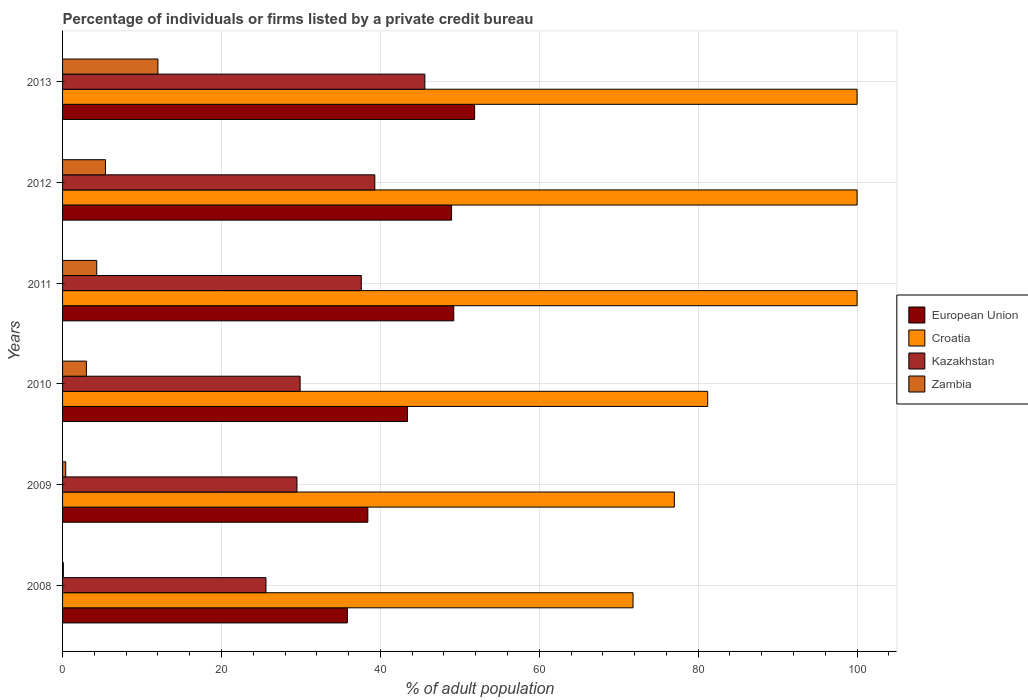How many different coloured bars are there?
Offer a very short reply. 4. How many groups of bars are there?
Offer a terse response. 6. Are the number of bars on each tick of the Y-axis equal?
Your answer should be very brief. Yes. How many bars are there on the 3rd tick from the top?
Provide a short and direct response. 4. How many bars are there on the 4th tick from the bottom?
Make the answer very short. 4. What is the label of the 1st group of bars from the top?
Your answer should be compact. 2013. What is the percentage of population listed by a private credit bureau in Zambia in 2011?
Give a very brief answer. 4.3. Across all years, what is the maximum percentage of population listed by a private credit bureau in Kazakhstan?
Your answer should be compact. 45.6. Across all years, what is the minimum percentage of population listed by a private credit bureau in Kazakhstan?
Ensure brevity in your answer.  25.6. In which year was the percentage of population listed by a private credit bureau in Kazakhstan maximum?
Offer a terse response. 2013. What is the total percentage of population listed by a private credit bureau in Zambia in the graph?
Provide a short and direct response. 25.2. What is the difference between the percentage of population listed by a private credit bureau in European Union in 2011 and the percentage of population listed by a private credit bureau in Croatia in 2008?
Provide a short and direct response. -22.56. In the year 2008, what is the difference between the percentage of population listed by a private credit bureau in Croatia and percentage of population listed by a private credit bureau in Zambia?
Keep it short and to the point. 71.7. In how many years, is the percentage of population listed by a private credit bureau in Kazakhstan greater than 56 %?
Provide a succinct answer. 0. What is the ratio of the percentage of population listed by a private credit bureau in European Union in 2009 to that in 2011?
Give a very brief answer. 0.78. Is the difference between the percentage of population listed by a private credit bureau in Croatia in 2011 and 2012 greater than the difference between the percentage of population listed by a private credit bureau in Zambia in 2011 and 2012?
Your answer should be compact. Yes. What is the difference between the highest and the lowest percentage of population listed by a private credit bureau in Kazakhstan?
Keep it short and to the point. 20. Is it the case that in every year, the sum of the percentage of population listed by a private credit bureau in Zambia and percentage of population listed by a private credit bureau in Croatia is greater than the sum of percentage of population listed by a private credit bureau in European Union and percentage of population listed by a private credit bureau in Kazakhstan?
Your answer should be compact. Yes. What does the 1st bar from the top in 2010 represents?
Your answer should be compact. Zambia. What does the 4th bar from the bottom in 2008 represents?
Give a very brief answer. Zambia. How many bars are there?
Your answer should be compact. 24. How many years are there in the graph?
Your answer should be very brief. 6. What is the difference between two consecutive major ticks on the X-axis?
Ensure brevity in your answer.  20. Are the values on the major ticks of X-axis written in scientific E-notation?
Ensure brevity in your answer.  No. Does the graph contain any zero values?
Your response must be concise. No. Does the graph contain grids?
Give a very brief answer. Yes. How many legend labels are there?
Keep it short and to the point. 4. What is the title of the graph?
Offer a terse response. Percentage of individuals or firms listed by a private credit bureau. What is the label or title of the X-axis?
Offer a very short reply. % of adult population. What is the label or title of the Y-axis?
Give a very brief answer. Years. What is the % of adult population of European Union in 2008?
Your answer should be compact. 35.84. What is the % of adult population of Croatia in 2008?
Your answer should be very brief. 71.8. What is the % of adult population of Kazakhstan in 2008?
Provide a short and direct response. 25.6. What is the % of adult population of European Union in 2009?
Give a very brief answer. 38.42. What is the % of adult population of Kazakhstan in 2009?
Your response must be concise. 29.5. What is the % of adult population of European Union in 2010?
Offer a terse response. 43.41. What is the % of adult population in Croatia in 2010?
Keep it short and to the point. 81.2. What is the % of adult population of Kazakhstan in 2010?
Your response must be concise. 29.9. What is the % of adult population of European Union in 2011?
Your answer should be compact. 49.24. What is the % of adult population of Croatia in 2011?
Offer a very short reply. 100. What is the % of adult population in Kazakhstan in 2011?
Keep it short and to the point. 37.6. What is the % of adult population of European Union in 2012?
Ensure brevity in your answer.  48.96. What is the % of adult population of Croatia in 2012?
Your answer should be compact. 100. What is the % of adult population of Kazakhstan in 2012?
Your answer should be very brief. 39.3. What is the % of adult population in European Union in 2013?
Give a very brief answer. 51.86. What is the % of adult population of Kazakhstan in 2013?
Make the answer very short. 45.6. Across all years, what is the maximum % of adult population of European Union?
Provide a short and direct response. 51.86. Across all years, what is the maximum % of adult population of Kazakhstan?
Make the answer very short. 45.6. Across all years, what is the minimum % of adult population of European Union?
Ensure brevity in your answer.  35.84. Across all years, what is the minimum % of adult population in Croatia?
Your response must be concise. 71.8. Across all years, what is the minimum % of adult population of Kazakhstan?
Make the answer very short. 25.6. Across all years, what is the minimum % of adult population of Zambia?
Offer a terse response. 0.1. What is the total % of adult population in European Union in the graph?
Ensure brevity in your answer.  267.75. What is the total % of adult population in Croatia in the graph?
Provide a succinct answer. 530. What is the total % of adult population in Kazakhstan in the graph?
Your answer should be compact. 207.5. What is the total % of adult population of Zambia in the graph?
Keep it short and to the point. 25.2. What is the difference between the % of adult population of European Union in 2008 and that in 2009?
Make the answer very short. -2.58. What is the difference between the % of adult population in European Union in 2008 and that in 2010?
Provide a succinct answer. -7.57. What is the difference between the % of adult population of Croatia in 2008 and that in 2010?
Provide a short and direct response. -9.4. What is the difference between the % of adult population in European Union in 2008 and that in 2011?
Your response must be concise. -13.39. What is the difference between the % of adult population in Croatia in 2008 and that in 2011?
Give a very brief answer. -28.2. What is the difference between the % of adult population in Kazakhstan in 2008 and that in 2011?
Offer a terse response. -12. What is the difference between the % of adult population in Zambia in 2008 and that in 2011?
Provide a succinct answer. -4.2. What is the difference between the % of adult population of European Union in 2008 and that in 2012?
Offer a terse response. -13.12. What is the difference between the % of adult population in Croatia in 2008 and that in 2012?
Provide a short and direct response. -28.2. What is the difference between the % of adult population in Kazakhstan in 2008 and that in 2012?
Offer a terse response. -13.7. What is the difference between the % of adult population of European Union in 2008 and that in 2013?
Give a very brief answer. -16.02. What is the difference between the % of adult population of Croatia in 2008 and that in 2013?
Provide a succinct answer. -28.2. What is the difference between the % of adult population in Zambia in 2008 and that in 2013?
Give a very brief answer. -11.9. What is the difference between the % of adult population of European Union in 2009 and that in 2010?
Offer a terse response. -4.99. What is the difference between the % of adult population of Kazakhstan in 2009 and that in 2010?
Offer a terse response. -0.4. What is the difference between the % of adult population in European Union in 2009 and that in 2011?
Your answer should be very brief. -10.82. What is the difference between the % of adult population of European Union in 2009 and that in 2012?
Your answer should be very brief. -10.54. What is the difference between the % of adult population of Croatia in 2009 and that in 2012?
Ensure brevity in your answer.  -23. What is the difference between the % of adult population in European Union in 2009 and that in 2013?
Offer a terse response. -13.44. What is the difference between the % of adult population in Kazakhstan in 2009 and that in 2013?
Give a very brief answer. -16.1. What is the difference between the % of adult population in Zambia in 2009 and that in 2013?
Offer a terse response. -11.6. What is the difference between the % of adult population of European Union in 2010 and that in 2011?
Offer a very short reply. -5.82. What is the difference between the % of adult population of Croatia in 2010 and that in 2011?
Make the answer very short. -18.8. What is the difference between the % of adult population of European Union in 2010 and that in 2012?
Provide a short and direct response. -5.55. What is the difference between the % of adult population of Croatia in 2010 and that in 2012?
Provide a succinct answer. -18.8. What is the difference between the % of adult population of Kazakhstan in 2010 and that in 2012?
Your answer should be very brief. -9.4. What is the difference between the % of adult population in Zambia in 2010 and that in 2012?
Offer a very short reply. -2.4. What is the difference between the % of adult population of European Union in 2010 and that in 2013?
Provide a succinct answer. -8.45. What is the difference between the % of adult population of Croatia in 2010 and that in 2013?
Provide a succinct answer. -18.8. What is the difference between the % of adult population of Kazakhstan in 2010 and that in 2013?
Ensure brevity in your answer.  -15.7. What is the difference between the % of adult population of Zambia in 2010 and that in 2013?
Keep it short and to the point. -9. What is the difference between the % of adult population of European Union in 2011 and that in 2012?
Make the answer very short. 0.28. What is the difference between the % of adult population of European Union in 2011 and that in 2013?
Ensure brevity in your answer.  -2.62. What is the difference between the % of adult population of Kazakhstan in 2011 and that in 2013?
Your response must be concise. -8. What is the difference between the % of adult population of European Union in 2012 and that in 2013?
Provide a succinct answer. -2.9. What is the difference between the % of adult population of Croatia in 2012 and that in 2013?
Ensure brevity in your answer.  0. What is the difference between the % of adult population in European Union in 2008 and the % of adult population in Croatia in 2009?
Your answer should be very brief. -41.16. What is the difference between the % of adult population of European Union in 2008 and the % of adult population of Kazakhstan in 2009?
Provide a short and direct response. 6.34. What is the difference between the % of adult population of European Union in 2008 and the % of adult population of Zambia in 2009?
Ensure brevity in your answer.  35.44. What is the difference between the % of adult population of Croatia in 2008 and the % of adult population of Kazakhstan in 2009?
Your response must be concise. 42.3. What is the difference between the % of adult population in Croatia in 2008 and the % of adult population in Zambia in 2009?
Give a very brief answer. 71.4. What is the difference between the % of adult population of Kazakhstan in 2008 and the % of adult population of Zambia in 2009?
Keep it short and to the point. 25.2. What is the difference between the % of adult population in European Union in 2008 and the % of adult population in Croatia in 2010?
Your answer should be very brief. -45.36. What is the difference between the % of adult population in European Union in 2008 and the % of adult population in Kazakhstan in 2010?
Your answer should be very brief. 5.94. What is the difference between the % of adult population of European Union in 2008 and the % of adult population of Zambia in 2010?
Your response must be concise. 32.84. What is the difference between the % of adult population in Croatia in 2008 and the % of adult population in Kazakhstan in 2010?
Your response must be concise. 41.9. What is the difference between the % of adult population of Croatia in 2008 and the % of adult population of Zambia in 2010?
Offer a terse response. 68.8. What is the difference between the % of adult population in Kazakhstan in 2008 and the % of adult population in Zambia in 2010?
Offer a very short reply. 22.6. What is the difference between the % of adult population in European Union in 2008 and the % of adult population in Croatia in 2011?
Your answer should be very brief. -64.16. What is the difference between the % of adult population in European Union in 2008 and the % of adult population in Kazakhstan in 2011?
Provide a succinct answer. -1.76. What is the difference between the % of adult population of European Union in 2008 and the % of adult population of Zambia in 2011?
Your answer should be compact. 31.54. What is the difference between the % of adult population in Croatia in 2008 and the % of adult population in Kazakhstan in 2011?
Offer a terse response. 34.2. What is the difference between the % of adult population of Croatia in 2008 and the % of adult population of Zambia in 2011?
Your answer should be very brief. 67.5. What is the difference between the % of adult population of Kazakhstan in 2008 and the % of adult population of Zambia in 2011?
Offer a terse response. 21.3. What is the difference between the % of adult population in European Union in 2008 and the % of adult population in Croatia in 2012?
Provide a succinct answer. -64.16. What is the difference between the % of adult population of European Union in 2008 and the % of adult population of Kazakhstan in 2012?
Give a very brief answer. -3.46. What is the difference between the % of adult population of European Union in 2008 and the % of adult population of Zambia in 2012?
Provide a short and direct response. 30.44. What is the difference between the % of adult population of Croatia in 2008 and the % of adult population of Kazakhstan in 2012?
Keep it short and to the point. 32.5. What is the difference between the % of adult population of Croatia in 2008 and the % of adult population of Zambia in 2012?
Provide a succinct answer. 66.4. What is the difference between the % of adult population in Kazakhstan in 2008 and the % of adult population in Zambia in 2012?
Provide a short and direct response. 20.2. What is the difference between the % of adult population in European Union in 2008 and the % of adult population in Croatia in 2013?
Provide a short and direct response. -64.16. What is the difference between the % of adult population in European Union in 2008 and the % of adult population in Kazakhstan in 2013?
Provide a short and direct response. -9.76. What is the difference between the % of adult population of European Union in 2008 and the % of adult population of Zambia in 2013?
Keep it short and to the point. 23.84. What is the difference between the % of adult population in Croatia in 2008 and the % of adult population in Kazakhstan in 2013?
Offer a very short reply. 26.2. What is the difference between the % of adult population in Croatia in 2008 and the % of adult population in Zambia in 2013?
Give a very brief answer. 59.8. What is the difference between the % of adult population in European Union in 2009 and the % of adult population in Croatia in 2010?
Provide a succinct answer. -42.78. What is the difference between the % of adult population in European Union in 2009 and the % of adult population in Kazakhstan in 2010?
Provide a short and direct response. 8.52. What is the difference between the % of adult population in European Union in 2009 and the % of adult population in Zambia in 2010?
Your answer should be compact. 35.42. What is the difference between the % of adult population in Croatia in 2009 and the % of adult population in Kazakhstan in 2010?
Provide a succinct answer. 47.1. What is the difference between the % of adult population of Croatia in 2009 and the % of adult population of Zambia in 2010?
Provide a succinct answer. 74. What is the difference between the % of adult population in Kazakhstan in 2009 and the % of adult population in Zambia in 2010?
Give a very brief answer. 26.5. What is the difference between the % of adult population in European Union in 2009 and the % of adult population in Croatia in 2011?
Provide a succinct answer. -61.58. What is the difference between the % of adult population of European Union in 2009 and the % of adult population of Kazakhstan in 2011?
Your response must be concise. 0.82. What is the difference between the % of adult population of European Union in 2009 and the % of adult population of Zambia in 2011?
Provide a succinct answer. 34.12. What is the difference between the % of adult population in Croatia in 2009 and the % of adult population in Kazakhstan in 2011?
Ensure brevity in your answer.  39.4. What is the difference between the % of adult population of Croatia in 2009 and the % of adult population of Zambia in 2011?
Keep it short and to the point. 72.7. What is the difference between the % of adult population of Kazakhstan in 2009 and the % of adult population of Zambia in 2011?
Make the answer very short. 25.2. What is the difference between the % of adult population in European Union in 2009 and the % of adult population in Croatia in 2012?
Your response must be concise. -61.58. What is the difference between the % of adult population in European Union in 2009 and the % of adult population in Kazakhstan in 2012?
Offer a terse response. -0.88. What is the difference between the % of adult population in European Union in 2009 and the % of adult population in Zambia in 2012?
Make the answer very short. 33.02. What is the difference between the % of adult population in Croatia in 2009 and the % of adult population in Kazakhstan in 2012?
Offer a terse response. 37.7. What is the difference between the % of adult population of Croatia in 2009 and the % of adult population of Zambia in 2012?
Give a very brief answer. 71.6. What is the difference between the % of adult population of Kazakhstan in 2009 and the % of adult population of Zambia in 2012?
Ensure brevity in your answer.  24.1. What is the difference between the % of adult population of European Union in 2009 and the % of adult population of Croatia in 2013?
Your answer should be very brief. -61.58. What is the difference between the % of adult population in European Union in 2009 and the % of adult population in Kazakhstan in 2013?
Give a very brief answer. -7.18. What is the difference between the % of adult population of European Union in 2009 and the % of adult population of Zambia in 2013?
Provide a short and direct response. 26.42. What is the difference between the % of adult population in Croatia in 2009 and the % of adult population in Kazakhstan in 2013?
Provide a succinct answer. 31.4. What is the difference between the % of adult population of Kazakhstan in 2009 and the % of adult population of Zambia in 2013?
Give a very brief answer. 17.5. What is the difference between the % of adult population in European Union in 2010 and the % of adult population in Croatia in 2011?
Your response must be concise. -56.59. What is the difference between the % of adult population in European Union in 2010 and the % of adult population in Kazakhstan in 2011?
Offer a very short reply. 5.81. What is the difference between the % of adult population in European Union in 2010 and the % of adult population in Zambia in 2011?
Your answer should be very brief. 39.11. What is the difference between the % of adult population of Croatia in 2010 and the % of adult population of Kazakhstan in 2011?
Ensure brevity in your answer.  43.6. What is the difference between the % of adult population of Croatia in 2010 and the % of adult population of Zambia in 2011?
Keep it short and to the point. 76.9. What is the difference between the % of adult population in Kazakhstan in 2010 and the % of adult population in Zambia in 2011?
Provide a succinct answer. 25.6. What is the difference between the % of adult population in European Union in 2010 and the % of adult population in Croatia in 2012?
Keep it short and to the point. -56.59. What is the difference between the % of adult population of European Union in 2010 and the % of adult population of Kazakhstan in 2012?
Your answer should be very brief. 4.11. What is the difference between the % of adult population in European Union in 2010 and the % of adult population in Zambia in 2012?
Provide a succinct answer. 38.01. What is the difference between the % of adult population of Croatia in 2010 and the % of adult population of Kazakhstan in 2012?
Your answer should be very brief. 41.9. What is the difference between the % of adult population in Croatia in 2010 and the % of adult population in Zambia in 2012?
Your answer should be compact. 75.8. What is the difference between the % of adult population in Kazakhstan in 2010 and the % of adult population in Zambia in 2012?
Your answer should be very brief. 24.5. What is the difference between the % of adult population of European Union in 2010 and the % of adult population of Croatia in 2013?
Provide a short and direct response. -56.59. What is the difference between the % of adult population in European Union in 2010 and the % of adult population in Kazakhstan in 2013?
Keep it short and to the point. -2.19. What is the difference between the % of adult population of European Union in 2010 and the % of adult population of Zambia in 2013?
Ensure brevity in your answer.  31.41. What is the difference between the % of adult population of Croatia in 2010 and the % of adult population of Kazakhstan in 2013?
Your answer should be very brief. 35.6. What is the difference between the % of adult population in Croatia in 2010 and the % of adult population in Zambia in 2013?
Ensure brevity in your answer.  69.2. What is the difference between the % of adult population of European Union in 2011 and the % of adult population of Croatia in 2012?
Provide a short and direct response. -50.76. What is the difference between the % of adult population in European Union in 2011 and the % of adult population in Kazakhstan in 2012?
Your response must be concise. 9.94. What is the difference between the % of adult population of European Union in 2011 and the % of adult population of Zambia in 2012?
Your answer should be compact. 43.84. What is the difference between the % of adult population in Croatia in 2011 and the % of adult population in Kazakhstan in 2012?
Your answer should be compact. 60.7. What is the difference between the % of adult population of Croatia in 2011 and the % of adult population of Zambia in 2012?
Your answer should be compact. 94.6. What is the difference between the % of adult population in Kazakhstan in 2011 and the % of adult population in Zambia in 2012?
Give a very brief answer. 32.2. What is the difference between the % of adult population in European Union in 2011 and the % of adult population in Croatia in 2013?
Offer a terse response. -50.76. What is the difference between the % of adult population of European Union in 2011 and the % of adult population of Kazakhstan in 2013?
Make the answer very short. 3.64. What is the difference between the % of adult population of European Union in 2011 and the % of adult population of Zambia in 2013?
Your answer should be compact. 37.24. What is the difference between the % of adult population in Croatia in 2011 and the % of adult population in Kazakhstan in 2013?
Provide a succinct answer. 54.4. What is the difference between the % of adult population of Croatia in 2011 and the % of adult population of Zambia in 2013?
Offer a very short reply. 88. What is the difference between the % of adult population in Kazakhstan in 2011 and the % of adult population in Zambia in 2013?
Give a very brief answer. 25.6. What is the difference between the % of adult population in European Union in 2012 and the % of adult population in Croatia in 2013?
Provide a short and direct response. -51.04. What is the difference between the % of adult population of European Union in 2012 and the % of adult population of Kazakhstan in 2013?
Make the answer very short. 3.36. What is the difference between the % of adult population of European Union in 2012 and the % of adult population of Zambia in 2013?
Your answer should be compact. 36.96. What is the difference between the % of adult population in Croatia in 2012 and the % of adult population in Kazakhstan in 2013?
Make the answer very short. 54.4. What is the difference between the % of adult population of Croatia in 2012 and the % of adult population of Zambia in 2013?
Give a very brief answer. 88. What is the difference between the % of adult population of Kazakhstan in 2012 and the % of adult population of Zambia in 2013?
Your response must be concise. 27.3. What is the average % of adult population in European Union per year?
Offer a terse response. 44.62. What is the average % of adult population in Croatia per year?
Your answer should be compact. 88.33. What is the average % of adult population in Kazakhstan per year?
Ensure brevity in your answer.  34.58. What is the average % of adult population in Zambia per year?
Ensure brevity in your answer.  4.2. In the year 2008, what is the difference between the % of adult population in European Union and % of adult population in Croatia?
Offer a terse response. -35.96. In the year 2008, what is the difference between the % of adult population in European Union and % of adult population in Kazakhstan?
Give a very brief answer. 10.24. In the year 2008, what is the difference between the % of adult population in European Union and % of adult population in Zambia?
Your answer should be very brief. 35.74. In the year 2008, what is the difference between the % of adult population in Croatia and % of adult population in Kazakhstan?
Make the answer very short. 46.2. In the year 2008, what is the difference between the % of adult population of Croatia and % of adult population of Zambia?
Your answer should be very brief. 71.7. In the year 2008, what is the difference between the % of adult population in Kazakhstan and % of adult population in Zambia?
Keep it short and to the point. 25.5. In the year 2009, what is the difference between the % of adult population of European Union and % of adult population of Croatia?
Your answer should be very brief. -38.58. In the year 2009, what is the difference between the % of adult population of European Union and % of adult population of Kazakhstan?
Your response must be concise. 8.92. In the year 2009, what is the difference between the % of adult population of European Union and % of adult population of Zambia?
Your response must be concise. 38.02. In the year 2009, what is the difference between the % of adult population in Croatia and % of adult population in Kazakhstan?
Keep it short and to the point. 47.5. In the year 2009, what is the difference between the % of adult population in Croatia and % of adult population in Zambia?
Provide a short and direct response. 76.6. In the year 2009, what is the difference between the % of adult population of Kazakhstan and % of adult population of Zambia?
Make the answer very short. 29.1. In the year 2010, what is the difference between the % of adult population of European Union and % of adult population of Croatia?
Keep it short and to the point. -37.79. In the year 2010, what is the difference between the % of adult population of European Union and % of adult population of Kazakhstan?
Provide a short and direct response. 13.51. In the year 2010, what is the difference between the % of adult population in European Union and % of adult population in Zambia?
Your answer should be compact. 40.41. In the year 2010, what is the difference between the % of adult population in Croatia and % of adult population in Kazakhstan?
Make the answer very short. 51.3. In the year 2010, what is the difference between the % of adult population in Croatia and % of adult population in Zambia?
Your response must be concise. 78.2. In the year 2010, what is the difference between the % of adult population in Kazakhstan and % of adult population in Zambia?
Ensure brevity in your answer.  26.9. In the year 2011, what is the difference between the % of adult population in European Union and % of adult population in Croatia?
Provide a succinct answer. -50.76. In the year 2011, what is the difference between the % of adult population of European Union and % of adult population of Kazakhstan?
Your answer should be compact. 11.64. In the year 2011, what is the difference between the % of adult population of European Union and % of adult population of Zambia?
Keep it short and to the point. 44.94. In the year 2011, what is the difference between the % of adult population in Croatia and % of adult population in Kazakhstan?
Make the answer very short. 62.4. In the year 2011, what is the difference between the % of adult population in Croatia and % of adult population in Zambia?
Your answer should be compact. 95.7. In the year 2011, what is the difference between the % of adult population in Kazakhstan and % of adult population in Zambia?
Offer a very short reply. 33.3. In the year 2012, what is the difference between the % of adult population in European Union and % of adult population in Croatia?
Give a very brief answer. -51.04. In the year 2012, what is the difference between the % of adult population in European Union and % of adult population in Kazakhstan?
Ensure brevity in your answer.  9.66. In the year 2012, what is the difference between the % of adult population of European Union and % of adult population of Zambia?
Your answer should be compact. 43.56. In the year 2012, what is the difference between the % of adult population of Croatia and % of adult population of Kazakhstan?
Provide a short and direct response. 60.7. In the year 2012, what is the difference between the % of adult population in Croatia and % of adult population in Zambia?
Make the answer very short. 94.6. In the year 2012, what is the difference between the % of adult population in Kazakhstan and % of adult population in Zambia?
Give a very brief answer. 33.9. In the year 2013, what is the difference between the % of adult population in European Union and % of adult population in Croatia?
Give a very brief answer. -48.14. In the year 2013, what is the difference between the % of adult population in European Union and % of adult population in Kazakhstan?
Provide a short and direct response. 6.26. In the year 2013, what is the difference between the % of adult population of European Union and % of adult population of Zambia?
Offer a terse response. 39.86. In the year 2013, what is the difference between the % of adult population of Croatia and % of adult population of Kazakhstan?
Make the answer very short. 54.4. In the year 2013, what is the difference between the % of adult population of Croatia and % of adult population of Zambia?
Ensure brevity in your answer.  88. In the year 2013, what is the difference between the % of adult population in Kazakhstan and % of adult population in Zambia?
Give a very brief answer. 33.6. What is the ratio of the % of adult population in European Union in 2008 to that in 2009?
Your answer should be compact. 0.93. What is the ratio of the % of adult population in Croatia in 2008 to that in 2009?
Provide a succinct answer. 0.93. What is the ratio of the % of adult population in Kazakhstan in 2008 to that in 2009?
Provide a short and direct response. 0.87. What is the ratio of the % of adult population of Zambia in 2008 to that in 2009?
Offer a very short reply. 0.25. What is the ratio of the % of adult population in European Union in 2008 to that in 2010?
Offer a very short reply. 0.83. What is the ratio of the % of adult population in Croatia in 2008 to that in 2010?
Ensure brevity in your answer.  0.88. What is the ratio of the % of adult population of Kazakhstan in 2008 to that in 2010?
Your response must be concise. 0.86. What is the ratio of the % of adult population in Zambia in 2008 to that in 2010?
Keep it short and to the point. 0.03. What is the ratio of the % of adult population in European Union in 2008 to that in 2011?
Ensure brevity in your answer.  0.73. What is the ratio of the % of adult population of Croatia in 2008 to that in 2011?
Your response must be concise. 0.72. What is the ratio of the % of adult population in Kazakhstan in 2008 to that in 2011?
Make the answer very short. 0.68. What is the ratio of the % of adult population in Zambia in 2008 to that in 2011?
Your answer should be compact. 0.02. What is the ratio of the % of adult population of European Union in 2008 to that in 2012?
Your answer should be compact. 0.73. What is the ratio of the % of adult population in Croatia in 2008 to that in 2012?
Your answer should be compact. 0.72. What is the ratio of the % of adult population of Kazakhstan in 2008 to that in 2012?
Ensure brevity in your answer.  0.65. What is the ratio of the % of adult population in Zambia in 2008 to that in 2012?
Offer a terse response. 0.02. What is the ratio of the % of adult population of European Union in 2008 to that in 2013?
Give a very brief answer. 0.69. What is the ratio of the % of adult population in Croatia in 2008 to that in 2013?
Offer a very short reply. 0.72. What is the ratio of the % of adult population of Kazakhstan in 2008 to that in 2013?
Ensure brevity in your answer.  0.56. What is the ratio of the % of adult population of Zambia in 2008 to that in 2013?
Keep it short and to the point. 0.01. What is the ratio of the % of adult population of European Union in 2009 to that in 2010?
Give a very brief answer. 0.89. What is the ratio of the % of adult population of Croatia in 2009 to that in 2010?
Your answer should be compact. 0.95. What is the ratio of the % of adult population of Kazakhstan in 2009 to that in 2010?
Offer a very short reply. 0.99. What is the ratio of the % of adult population of Zambia in 2009 to that in 2010?
Give a very brief answer. 0.13. What is the ratio of the % of adult population in European Union in 2009 to that in 2011?
Provide a succinct answer. 0.78. What is the ratio of the % of adult population in Croatia in 2009 to that in 2011?
Give a very brief answer. 0.77. What is the ratio of the % of adult population in Kazakhstan in 2009 to that in 2011?
Give a very brief answer. 0.78. What is the ratio of the % of adult population of Zambia in 2009 to that in 2011?
Give a very brief answer. 0.09. What is the ratio of the % of adult population of European Union in 2009 to that in 2012?
Ensure brevity in your answer.  0.78. What is the ratio of the % of adult population in Croatia in 2009 to that in 2012?
Your answer should be compact. 0.77. What is the ratio of the % of adult population in Kazakhstan in 2009 to that in 2012?
Keep it short and to the point. 0.75. What is the ratio of the % of adult population of Zambia in 2009 to that in 2012?
Make the answer very short. 0.07. What is the ratio of the % of adult population of European Union in 2009 to that in 2013?
Offer a very short reply. 0.74. What is the ratio of the % of adult population in Croatia in 2009 to that in 2013?
Make the answer very short. 0.77. What is the ratio of the % of adult population in Kazakhstan in 2009 to that in 2013?
Provide a short and direct response. 0.65. What is the ratio of the % of adult population of Zambia in 2009 to that in 2013?
Your answer should be very brief. 0.03. What is the ratio of the % of adult population of European Union in 2010 to that in 2011?
Your answer should be very brief. 0.88. What is the ratio of the % of adult population of Croatia in 2010 to that in 2011?
Your answer should be compact. 0.81. What is the ratio of the % of adult population of Kazakhstan in 2010 to that in 2011?
Offer a terse response. 0.8. What is the ratio of the % of adult population of Zambia in 2010 to that in 2011?
Your answer should be very brief. 0.7. What is the ratio of the % of adult population in European Union in 2010 to that in 2012?
Ensure brevity in your answer.  0.89. What is the ratio of the % of adult population in Croatia in 2010 to that in 2012?
Your answer should be compact. 0.81. What is the ratio of the % of adult population of Kazakhstan in 2010 to that in 2012?
Make the answer very short. 0.76. What is the ratio of the % of adult population in Zambia in 2010 to that in 2012?
Your answer should be very brief. 0.56. What is the ratio of the % of adult population of European Union in 2010 to that in 2013?
Offer a very short reply. 0.84. What is the ratio of the % of adult population of Croatia in 2010 to that in 2013?
Provide a succinct answer. 0.81. What is the ratio of the % of adult population of Kazakhstan in 2010 to that in 2013?
Your answer should be compact. 0.66. What is the ratio of the % of adult population of European Union in 2011 to that in 2012?
Your answer should be very brief. 1.01. What is the ratio of the % of adult population of Croatia in 2011 to that in 2012?
Provide a short and direct response. 1. What is the ratio of the % of adult population in Kazakhstan in 2011 to that in 2012?
Provide a short and direct response. 0.96. What is the ratio of the % of adult population in Zambia in 2011 to that in 2012?
Keep it short and to the point. 0.8. What is the ratio of the % of adult population in European Union in 2011 to that in 2013?
Offer a terse response. 0.95. What is the ratio of the % of adult population in Kazakhstan in 2011 to that in 2013?
Offer a terse response. 0.82. What is the ratio of the % of adult population of Zambia in 2011 to that in 2013?
Offer a very short reply. 0.36. What is the ratio of the % of adult population in European Union in 2012 to that in 2013?
Offer a very short reply. 0.94. What is the ratio of the % of adult population in Kazakhstan in 2012 to that in 2013?
Offer a very short reply. 0.86. What is the ratio of the % of adult population in Zambia in 2012 to that in 2013?
Make the answer very short. 0.45. What is the difference between the highest and the second highest % of adult population of European Union?
Provide a short and direct response. 2.62. What is the difference between the highest and the second highest % of adult population of Croatia?
Keep it short and to the point. 0. What is the difference between the highest and the second highest % of adult population of Zambia?
Provide a short and direct response. 6.6. What is the difference between the highest and the lowest % of adult population in European Union?
Provide a succinct answer. 16.02. What is the difference between the highest and the lowest % of adult population in Croatia?
Your response must be concise. 28.2. What is the difference between the highest and the lowest % of adult population in Kazakhstan?
Ensure brevity in your answer.  20. 